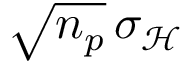Convert formula to latex. <formula><loc_0><loc_0><loc_500><loc_500>\sqrt { n _ { p } } \, \sigma _ { \mathcal { H } }</formula> 